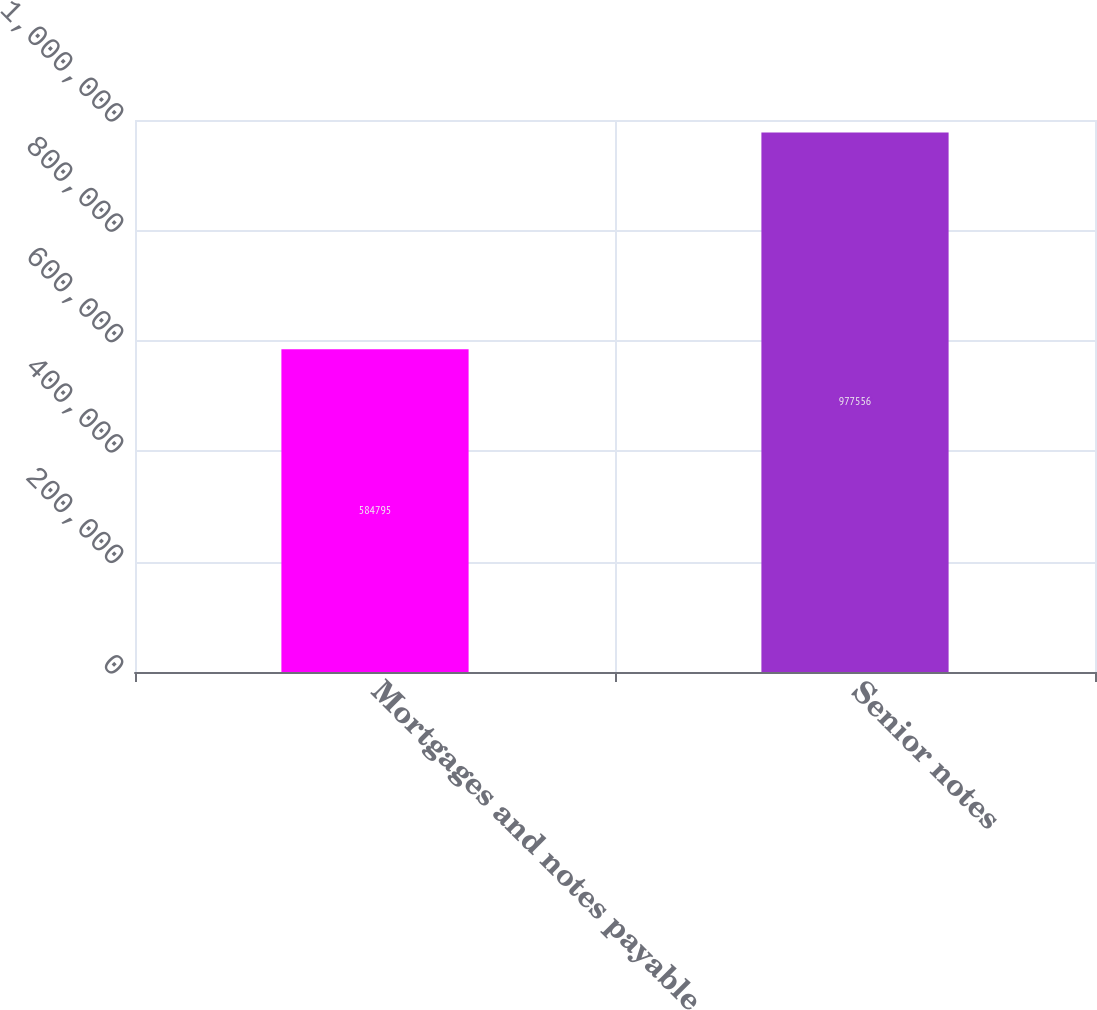Convert chart to OTSL. <chart><loc_0><loc_0><loc_500><loc_500><bar_chart><fcel>Mortgages and notes payable<fcel>Senior notes<nl><fcel>584795<fcel>977556<nl></chart> 